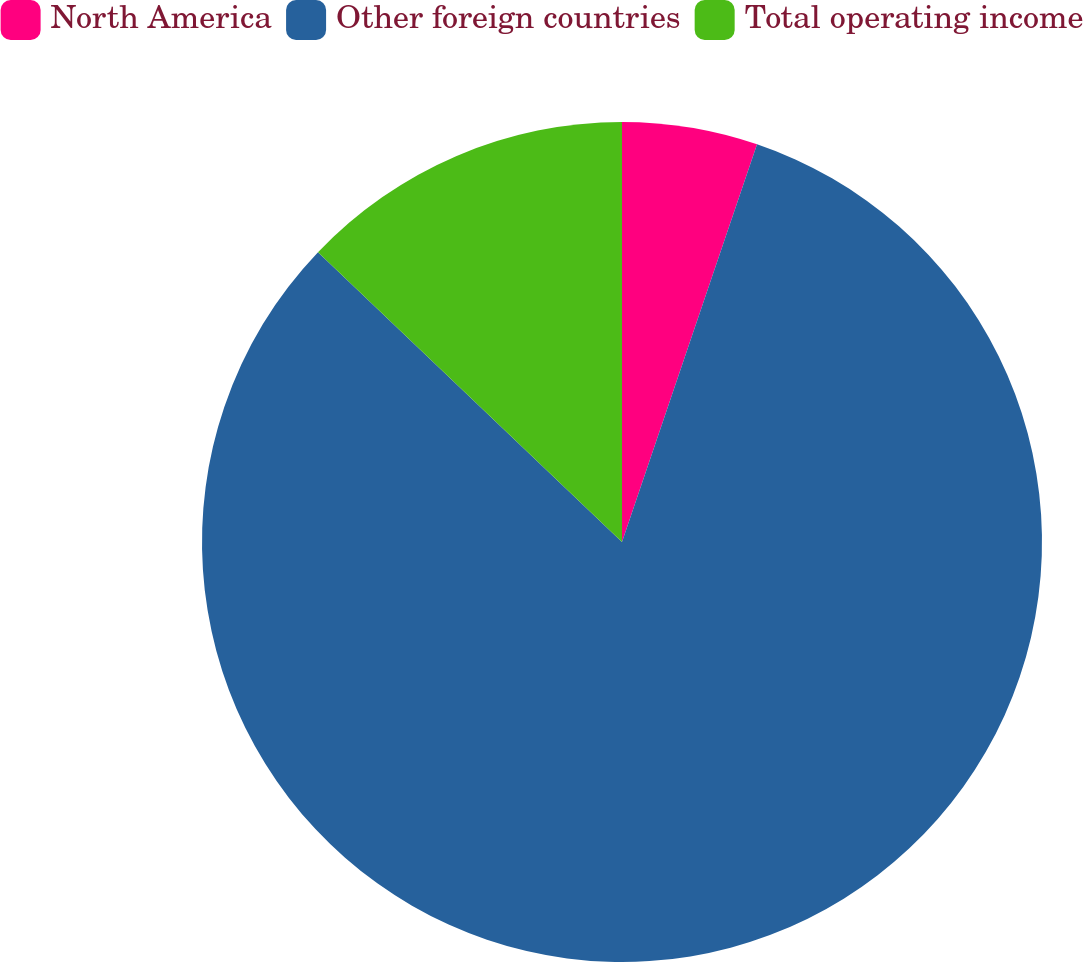<chart> <loc_0><loc_0><loc_500><loc_500><pie_chart><fcel>North America<fcel>Other foreign countries<fcel>Total operating income<nl><fcel>5.21%<fcel>81.91%<fcel>12.88%<nl></chart> 